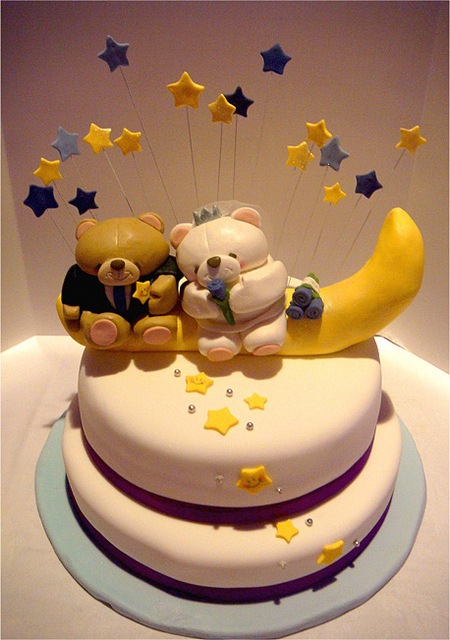<image>Is the cake real or fake? I am not sure if the cake is real or fake. The answers vary. What fruit is on top of the cake? I am not sure what fruit is on top of the cake. There could be a banana, strawberry or none. Is the cake real or fake? I am not sure if the cake is real or fake. It can be both real and fake. What fruit is on top of the cake? I am not sure what fruit is on top of the cake. But it can be seen as a banana and strawberry. 